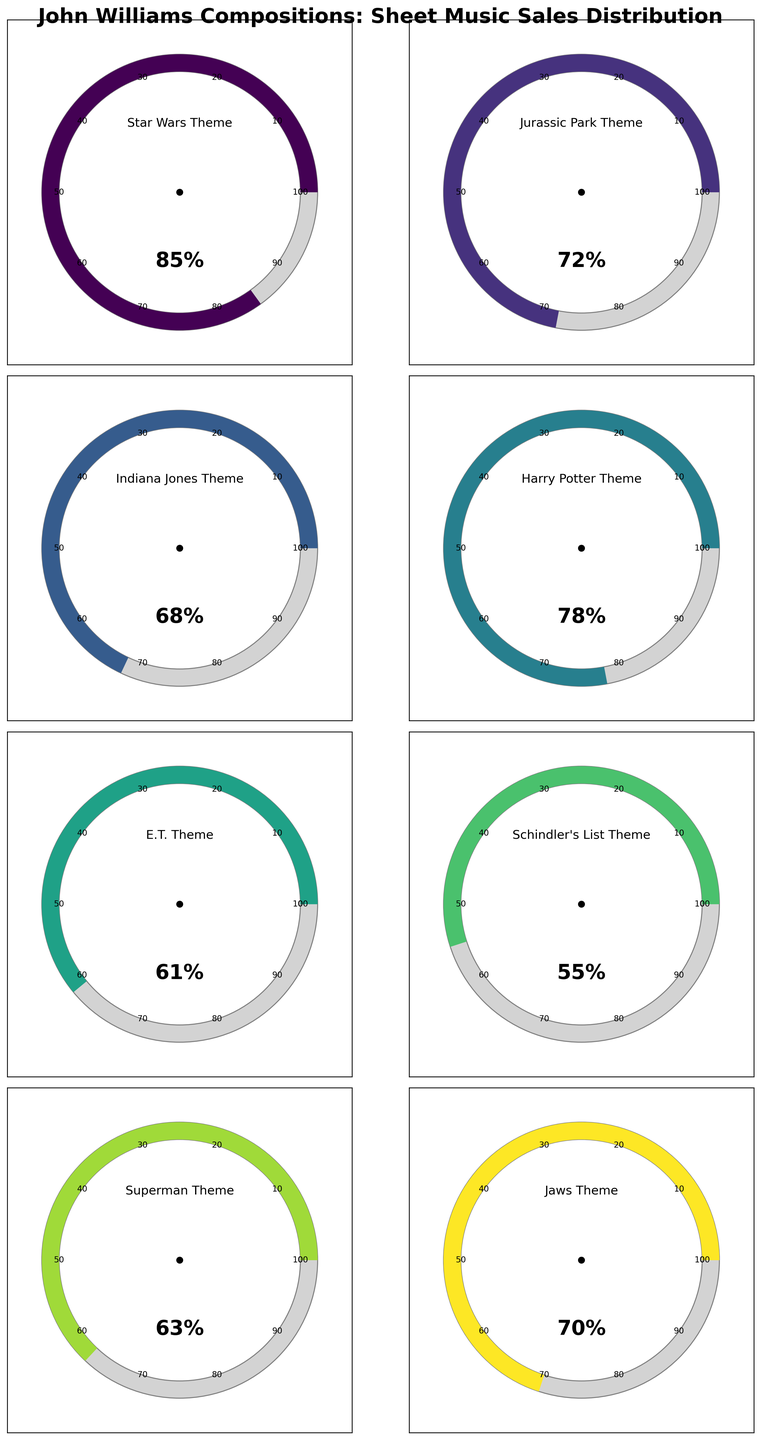what is the theme with the highest sheet music sales percentage? The theme with the highest sheet music sales is identified by finding the gauge with the highest percentage displayed on the plot. The Star Wars Theme has the highest value at 85%.
Answer: Star Wars Theme What is the difference in sheet music sales percentage between the E.T. Theme and the Jurassic Park Theme? To find the difference, subtract the percentage value of the E.T. Theme (61%) from the percentage value of the Jurassic Park Theme (72%). So, 72% - 61% = 11%.
Answer: 11% Which John Williams composition has the lowest sheet music sales percentage? The theme with the lowest percentage on its gauge represents the lowest sheet music sales. The Schindler's List Theme has the lowest value at 55%.
Answer: Schindler's List Theme What's the average percentage of sheet music sales for all the listed compositions? Add the percentage values of all the themes and divide by the number of themes. The sum is 85 + 72 + 68 + 78 + 61 + 55 + 63 + 70 = 552. There are 8 themes, so the average is 552 / 8 = 69%.
Answer: 69% How many compositions have sheet music sales percentages above 70%? Count the number of gauges with a percentage value above 70%. The themes with values above 70% are Star Wars Theme (85%), Jurassic Park Theme (72%), and Harry Potter Theme (78%), totaling 3 themes.
Answer: 3 Which themes have sheet music sales percentages between 60% and 70% inclusive? Identify the themes with percentages in the range of 60% to 70%. The themes are E.T. Theme (61%), Superman Theme (63%), and Jaws Theme (70%).
Answer: E.T. Theme, Superman Theme, Jaws Theme What's the percentage difference between the highest and lowest sheet music sales values? Subtract the lowest value (Schindler's List Theme, 55%) from the highest value (Star Wars Theme, 85%). So, 85% - 55% = 30%.
Answer: 30% Which two themes have sheet music sales percentages closest to each other in value? Determine the pairs of themes with the smallest difference in their values. The smallest difference is between the Superman Theme (63%) and the E.T. Theme (61%), a 2% difference.
Answer: E.T. Theme and Superman Theme What is the sum of the sheet music sales percentages for the Harry Potter Theme and the Indiana Jones Theme? Add the percentage values of the Harry Potter Theme (78%) and the Indiana Jones Theme (68%). So, 78% + 68% = 146%.
Answer: 146% 